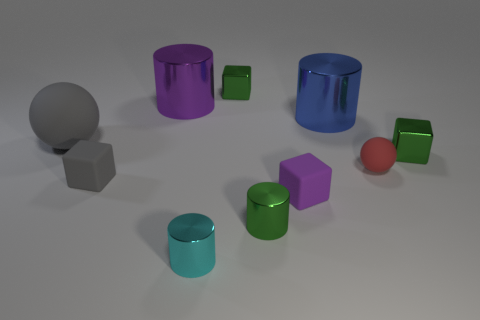Subtract all blocks. How many objects are left? 6 Add 1 blue metal blocks. How many blue metal blocks exist? 1 Subtract 0 blue cubes. How many objects are left? 10 Subtract all purple matte things. Subtract all small rubber things. How many objects are left? 6 Add 1 tiny red spheres. How many tiny red spheres are left? 2 